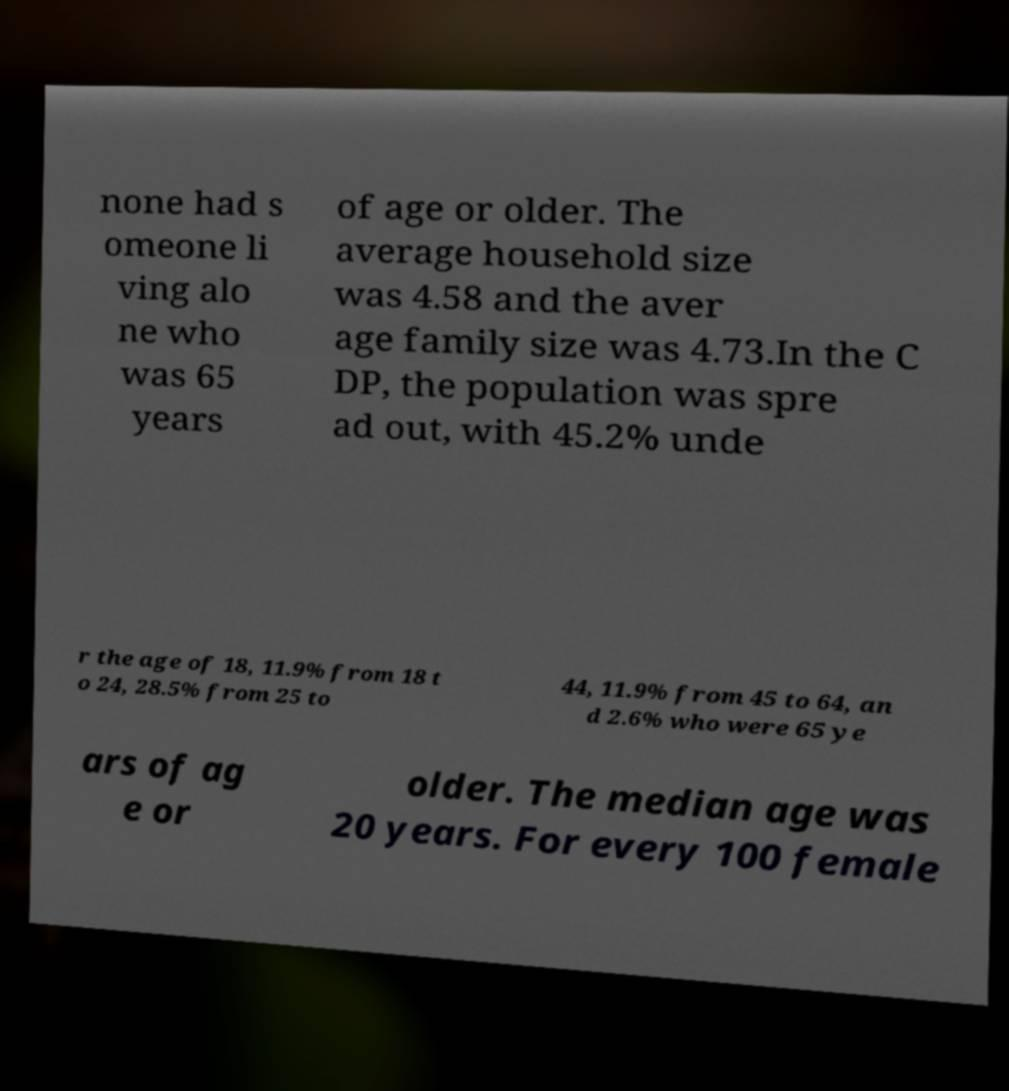Please read and relay the text visible in this image. What does it say? none had s omeone li ving alo ne who was 65 years of age or older. The average household size was 4.58 and the aver age family size was 4.73.In the C DP, the population was spre ad out, with 45.2% unde r the age of 18, 11.9% from 18 t o 24, 28.5% from 25 to 44, 11.9% from 45 to 64, an d 2.6% who were 65 ye ars of ag e or older. The median age was 20 years. For every 100 female 